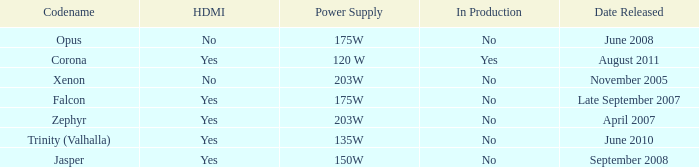Is Jasper being producted? No. 